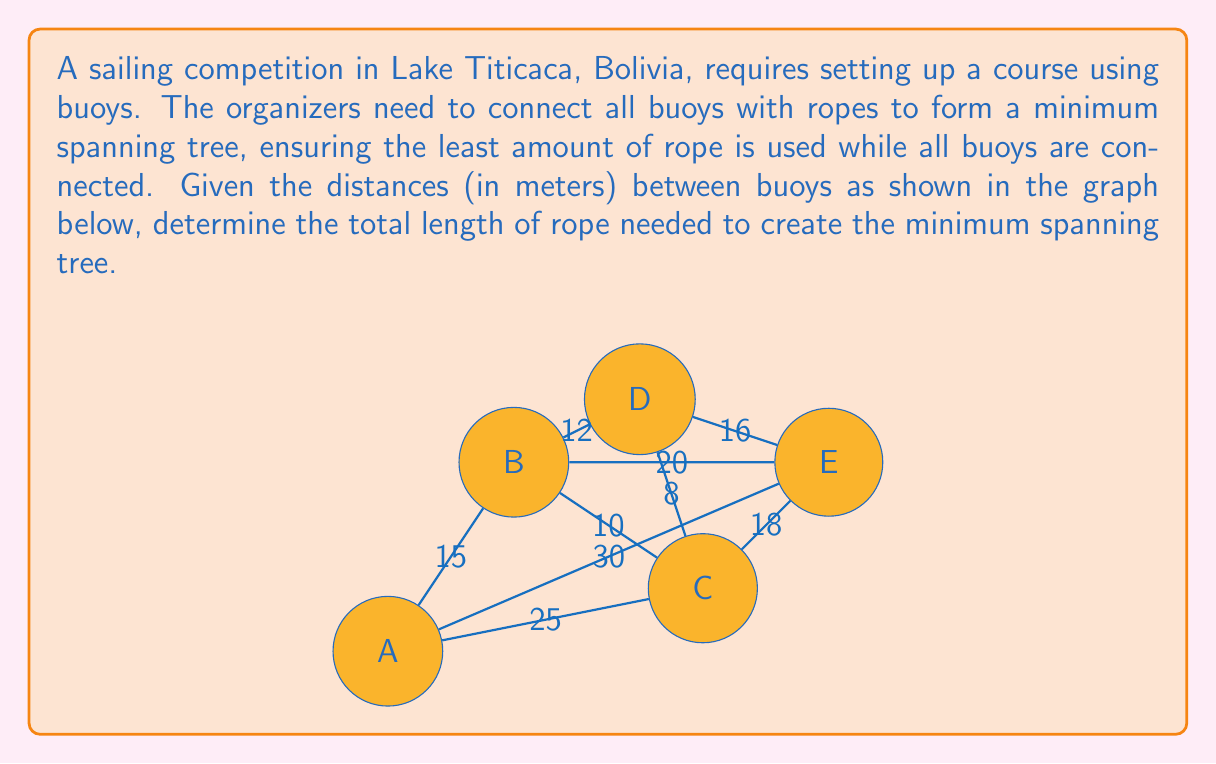What is the answer to this math problem? To solve this problem, we'll use Kruskal's algorithm to find the minimum spanning tree:

1) First, sort all edges by weight (distance) in ascending order:
   $$(C,D): 8, (B,C): 10, (B,D): 12, (A,B): 15, (C,E): 18, (B,E): 20, (A,C): 25, (A,E): 30, (D,E): 16$$

2) Start with an empty set of edges and add edges one by one, ensuring no cycles are formed:

   - Add $(C,D): 8$
   - Add $(B,C): 10$
   - Add $(B,D): 12$ (skipped as it would form a cycle)
   - Add $(A,B): 15$
   - Add $(D,E): 16$

3) At this point, all vertices are connected, and we have our minimum spanning tree.

4) Sum up the weights of the selected edges:
   $$8 + 10 + 15 + 16 = 49$$

Therefore, the minimum total length of rope needed is 49 meters.
Answer: 49 meters 